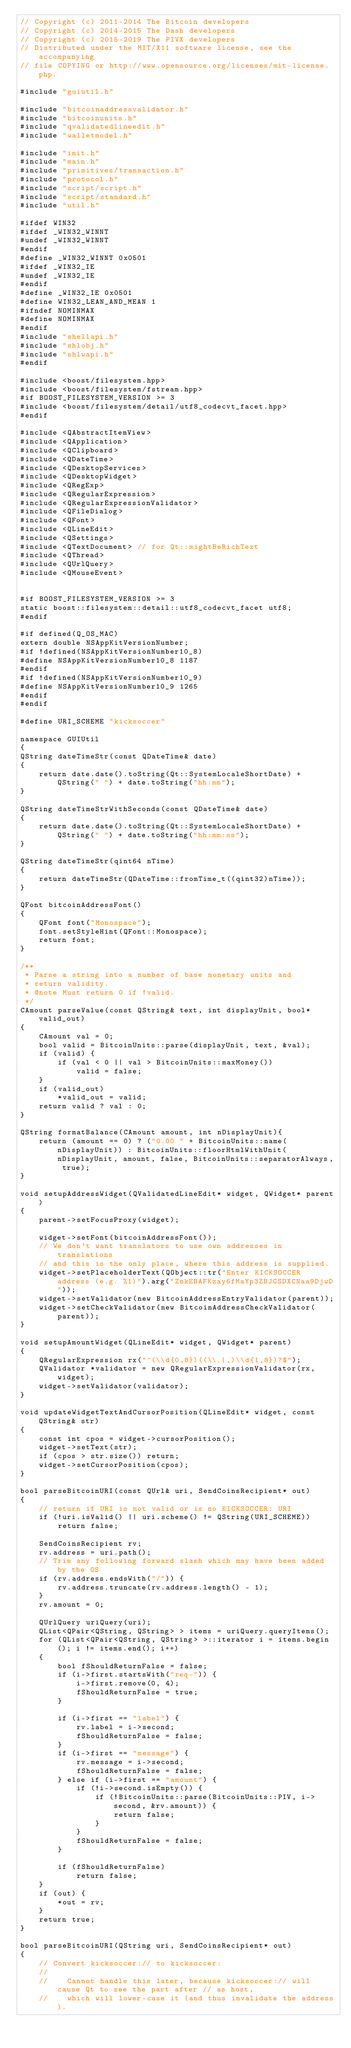Convert code to text. <code><loc_0><loc_0><loc_500><loc_500><_C++_>// Copyright (c) 2011-2014 The Bitcoin developers
// Copyright (c) 2014-2015 The Dash developers
// Copyright (c) 2015-2019 The PIVX developers
// Distributed under the MIT/X11 software license, see the accompanying
// file COPYING or http://www.opensource.org/licenses/mit-license.php.

#include "guiutil.h"

#include "bitcoinaddressvalidator.h"
#include "bitcoinunits.h"
#include "qvalidatedlineedit.h"
#include "walletmodel.h"

#include "init.h"
#include "main.h"
#include "primitives/transaction.h"
#include "protocol.h"
#include "script/script.h"
#include "script/standard.h"
#include "util.h"

#ifdef WIN32
#ifdef _WIN32_WINNT
#undef _WIN32_WINNT
#endif
#define _WIN32_WINNT 0x0501
#ifdef _WIN32_IE
#undef _WIN32_IE
#endif
#define _WIN32_IE 0x0501
#define WIN32_LEAN_AND_MEAN 1
#ifndef NOMINMAX
#define NOMINMAX
#endif
#include "shellapi.h"
#include "shlobj.h"
#include "shlwapi.h"
#endif

#include <boost/filesystem.hpp>
#include <boost/filesystem/fstream.hpp>
#if BOOST_FILESYSTEM_VERSION >= 3
#include <boost/filesystem/detail/utf8_codecvt_facet.hpp>
#endif

#include <QAbstractItemView>
#include <QApplication>
#include <QClipboard>
#include <QDateTime>
#include <QDesktopServices>
#include <QDesktopWidget>
#include <QRegExp>
#include <QRegularExpression>
#include <QRegularExpressionValidator>
#include <QFileDialog>
#include <QFont>
#include <QLineEdit>
#include <QSettings>
#include <QTextDocument> // for Qt::mightBeRichText
#include <QThread>
#include <QUrlQuery>
#include <QMouseEvent>


#if BOOST_FILESYSTEM_VERSION >= 3
static boost::filesystem::detail::utf8_codecvt_facet utf8;
#endif

#if defined(Q_OS_MAC)
extern double NSAppKitVersionNumber;
#if !defined(NSAppKitVersionNumber10_8)
#define NSAppKitVersionNumber10_8 1187
#endif
#if !defined(NSAppKitVersionNumber10_9)
#define NSAppKitVersionNumber10_9 1265
#endif
#endif

#define URI_SCHEME "kicksoccer"

namespace GUIUtil
{
QString dateTimeStr(const QDateTime& date)
{
    return date.date().toString(Qt::SystemLocaleShortDate) + QString(" ") + date.toString("hh:mm");
}

QString dateTimeStrWithSeconds(const QDateTime& date)
{
    return date.date().toString(Qt::SystemLocaleShortDate) + QString(" ") + date.toString("hh:mm:ss");
}

QString dateTimeStr(qint64 nTime)
{
    return dateTimeStr(QDateTime::fromTime_t((qint32)nTime));
}

QFont bitcoinAddressFont()
{
    QFont font("Monospace");
    font.setStyleHint(QFont::Monospace);
    return font;
}

/**
 * Parse a string into a number of base monetary units and
 * return validity.
 * @note Must return 0 if !valid.
 */
CAmount parseValue(const QString& text, int displayUnit, bool* valid_out)
{
    CAmount val = 0;
    bool valid = BitcoinUnits::parse(displayUnit, text, &val);
    if (valid) {
        if (val < 0 || val > BitcoinUnits::maxMoney())
            valid = false;
    }
    if (valid_out)
        *valid_out = valid;
    return valid ? val : 0;
}

QString formatBalance(CAmount amount, int nDisplayUnit){
    return (amount == 0) ? ("0.00 " + BitcoinUnits::name(nDisplayUnit)) : BitcoinUnits::floorHtmlWithUnit(nDisplayUnit, amount, false, BitcoinUnits::separatorAlways, true);
}

void setupAddressWidget(QValidatedLineEdit* widget, QWidget* parent)
{
    parent->setFocusProxy(widget);

    widget->setFont(bitcoinAddressFont());
    // We don't want translators to use own addresses in translations
    // and this is the only place, where this address is supplied.
    widget->setPlaceholderText(QObject::tr("Enter KICKSOCCER address (e.g. %1)").arg("ZmkEBAFKzay6fMaYp3ZBJGSDXCNaa9DjwD"));
    widget->setValidator(new BitcoinAddressEntryValidator(parent));
    widget->setCheckValidator(new BitcoinAddressCheckValidator(parent));
}

void setupAmountWidget(QLineEdit* widget, QWidget* parent)
{
    QRegularExpression rx("^(\\d{0,8})((\\.|,)\\d{1,8})?$");
    QValidator *validator = new QRegularExpressionValidator(rx, widget);
    widget->setValidator(validator);
}

void updateWidgetTextAndCursorPosition(QLineEdit* widget, const QString& str)
{
    const int cpos = widget->cursorPosition();
    widget->setText(str);
    if (cpos > str.size()) return;
    widget->setCursorPosition(cpos);
}

bool parseBitcoinURI(const QUrl& uri, SendCoinsRecipient* out)
{
    // return if URI is not valid or is no KICKSOCCER: URI
    if (!uri.isValid() || uri.scheme() != QString(URI_SCHEME))
        return false;

    SendCoinsRecipient rv;
    rv.address = uri.path();
    // Trim any following forward slash which may have been added by the OS
    if (rv.address.endsWith("/")) {
        rv.address.truncate(rv.address.length() - 1);
    }
    rv.amount = 0;

    QUrlQuery uriQuery(uri);
    QList<QPair<QString, QString> > items = uriQuery.queryItems();
    for (QList<QPair<QString, QString> >::iterator i = items.begin(); i != items.end(); i++)
    {
        bool fShouldReturnFalse = false;
        if (i->first.startsWith("req-")) {
            i->first.remove(0, 4);
            fShouldReturnFalse = true;
        }

        if (i->first == "label") {
            rv.label = i->second;
            fShouldReturnFalse = false;
        }
        if (i->first == "message") {
            rv.message = i->second;
            fShouldReturnFalse = false;
        } else if (i->first == "amount") {
            if (!i->second.isEmpty()) {
                if (!BitcoinUnits::parse(BitcoinUnits::PIV, i->second, &rv.amount)) {
                    return false;
                }
            }
            fShouldReturnFalse = false;
        }

        if (fShouldReturnFalse)
            return false;
    }
    if (out) {
        *out = rv;
    }
    return true;
}

bool parseBitcoinURI(QString uri, SendCoinsRecipient* out)
{
    // Convert kicksoccer:// to kicksoccer:
    //
    //    Cannot handle this later, because kicksoccer:// will cause Qt to see the part after // as host,
    //    which will lower-case it (and thus invalidate the address).</code> 